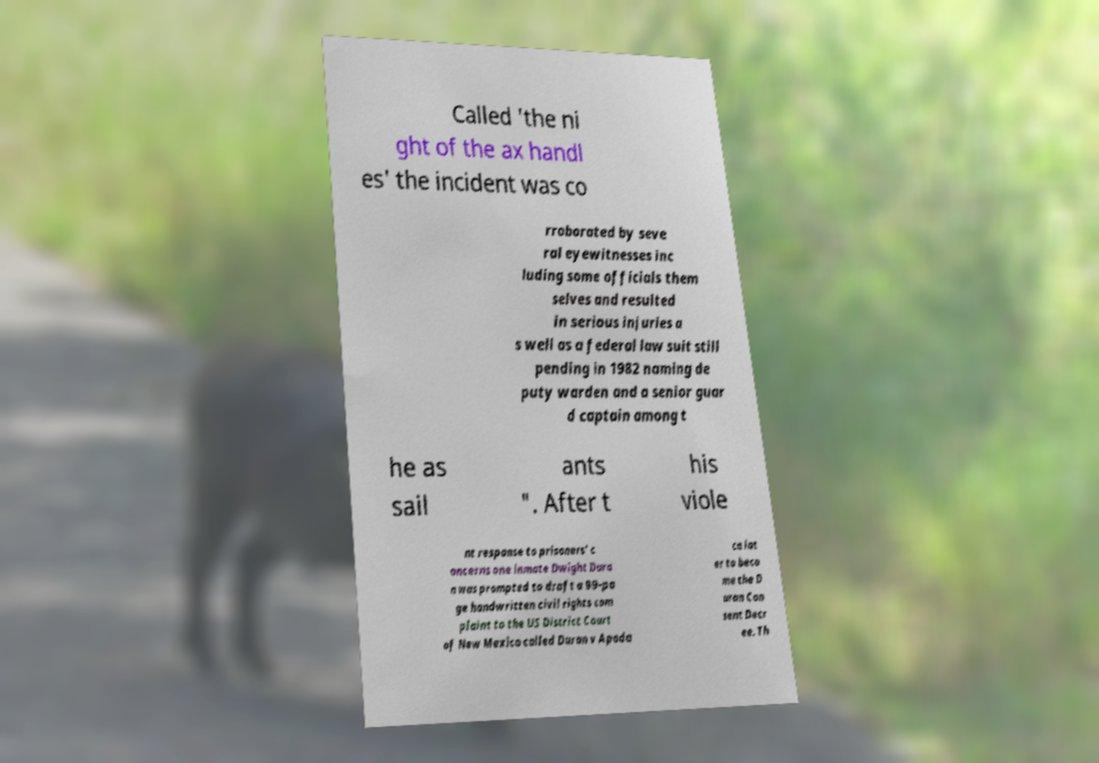Please read and relay the text visible in this image. What does it say? Called 'the ni ght of the ax handl es' the incident was co rroborated by seve ral eyewitnesses inc luding some officials them selves and resulted in serious injuries a s well as a federal law suit still pending in 1982 naming de puty warden and a senior guar d captain among t he as sail ants ". After t his viole nt response to prisoners' c oncerns one inmate Dwight Dura n was prompted to draft a 99-pa ge handwritten civil rights com plaint to the US District Court of New Mexico called Duran v Apoda ca lat er to beco me the D uran Con sent Decr ee. Th 